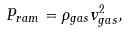Convert formula to latex. <formula><loc_0><loc_0><loc_500><loc_500>P _ { r a m } = \rho _ { g a s } v _ { g a s } ^ { 2 } ,</formula> 